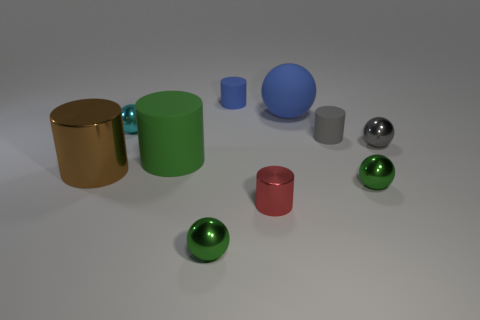Subtract all big blue spheres. How many spheres are left? 4 Subtract all brown cylinders. How many cylinders are left? 4 Subtract all yellow spheres. Subtract all red cylinders. How many spheres are left? 5 Add 2 large spheres. How many large spheres exist? 3 Subtract 0 purple spheres. How many objects are left? 10 Subtract all big brown rubber balls. Subtract all gray matte cylinders. How many objects are left? 9 Add 6 small red shiny objects. How many small red shiny objects are left? 7 